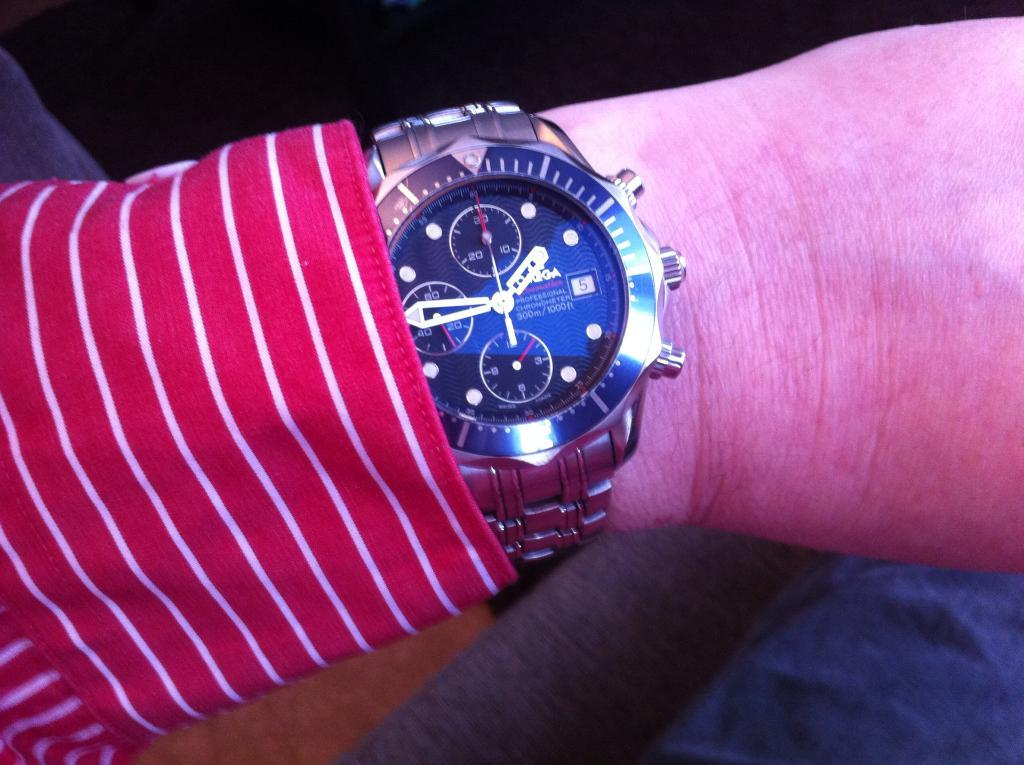<image>
Present a compact description of the photo's key features. A person wears a red and white striped shirt and an Omega watch. 